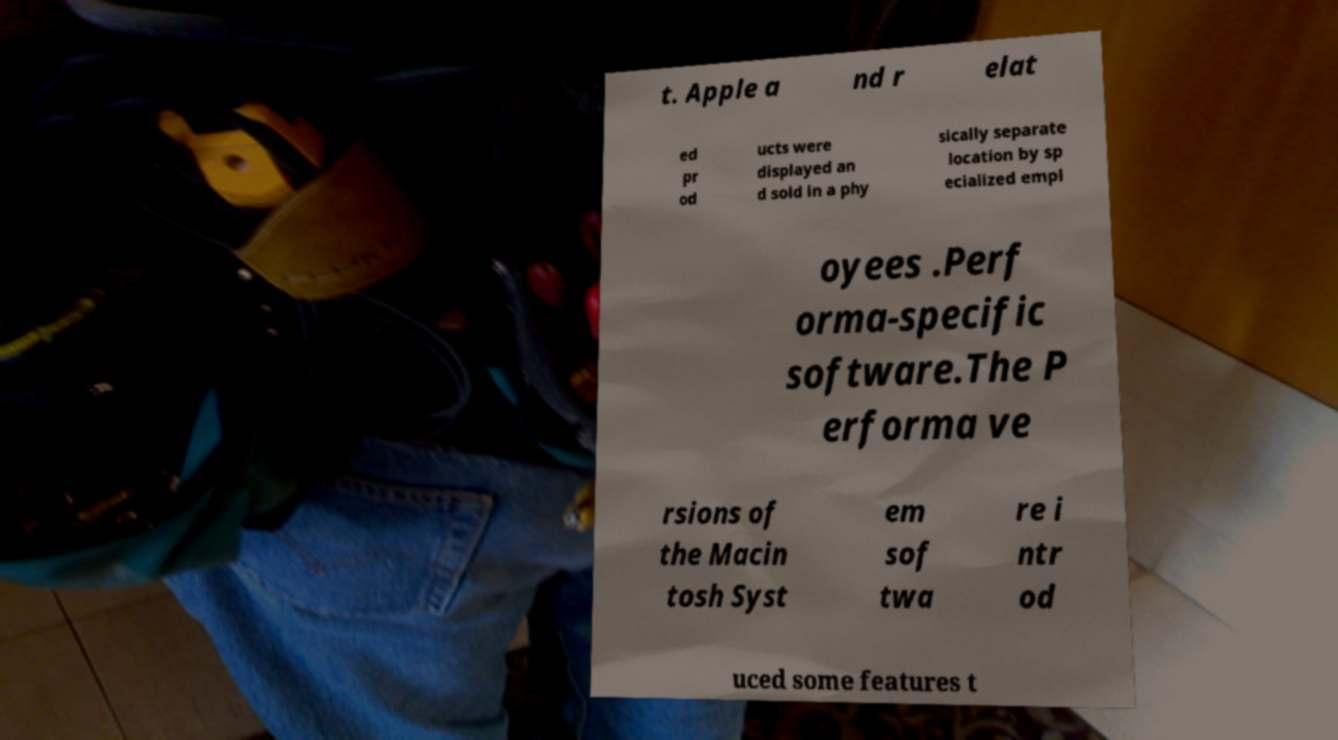Please identify and transcribe the text found in this image. t. Apple a nd r elat ed pr od ucts were displayed an d sold in a phy sically separate location by sp ecialized empl oyees .Perf orma-specific software.The P erforma ve rsions of the Macin tosh Syst em sof twa re i ntr od uced some features t 